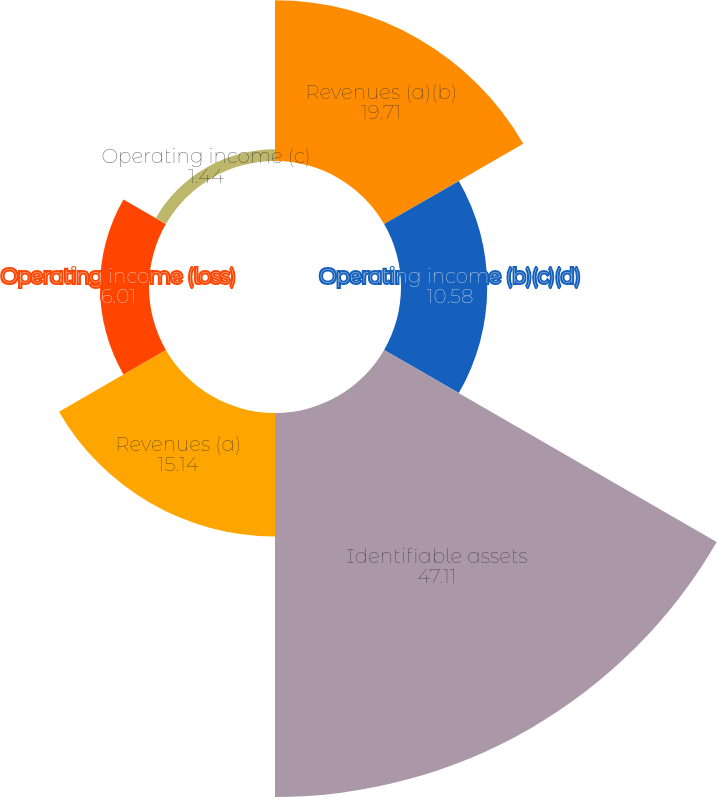<chart> <loc_0><loc_0><loc_500><loc_500><pie_chart><fcel>Revenues (a)(b)<fcel>Operating income (b)(c)(d)<fcel>Identifiable assets<fcel>Revenues (a)<fcel>Operating income (loss)<fcel>Operating income (c)<nl><fcel>19.71%<fcel>10.58%<fcel>47.11%<fcel>15.14%<fcel>6.01%<fcel>1.44%<nl></chart> 